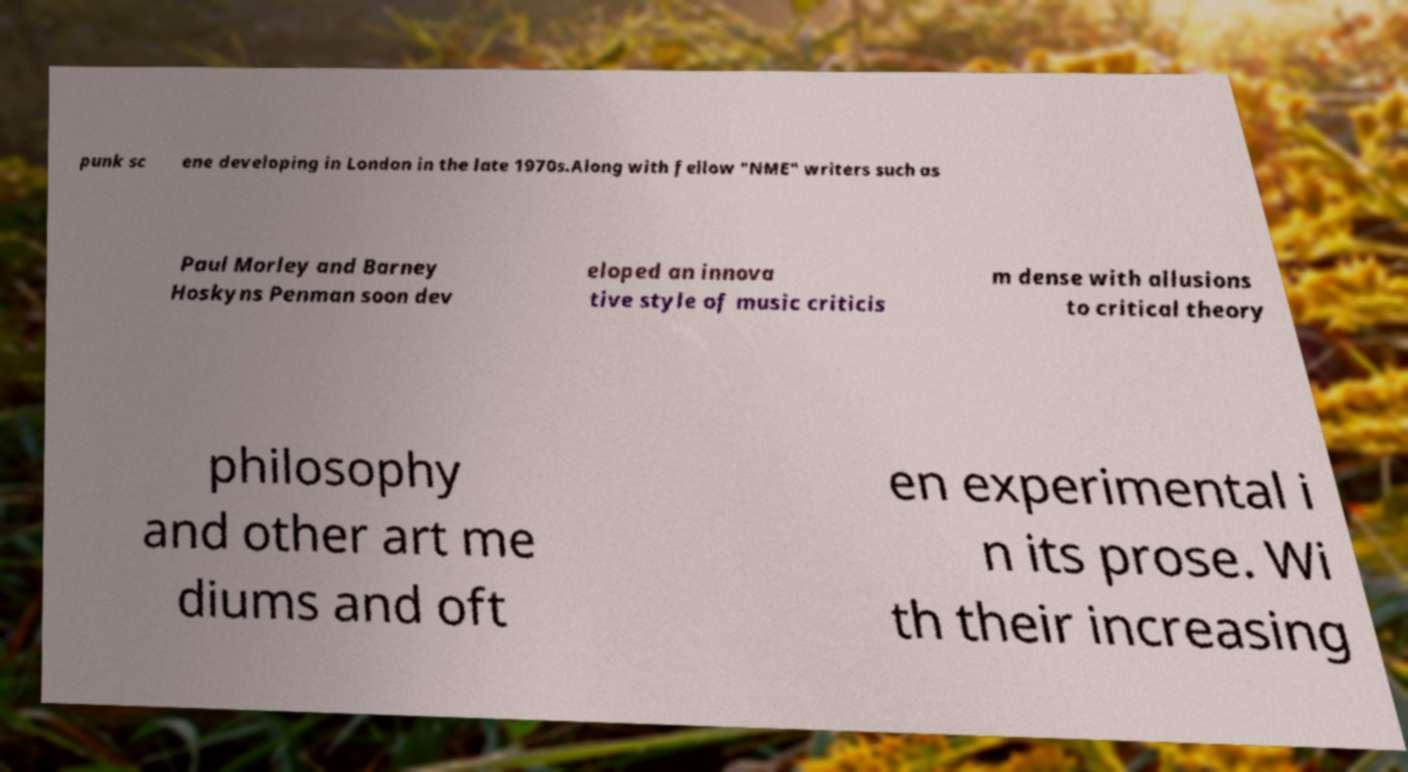There's text embedded in this image that I need extracted. Can you transcribe it verbatim? punk sc ene developing in London in the late 1970s.Along with fellow "NME" writers such as Paul Morley and Barney Hoskyns Penman soon dev eloped an innova tive style of music criticis m dense with allusions to critical theory philosophy and other art me diums and oft en experimental i n its prose. Wi th their increasing 